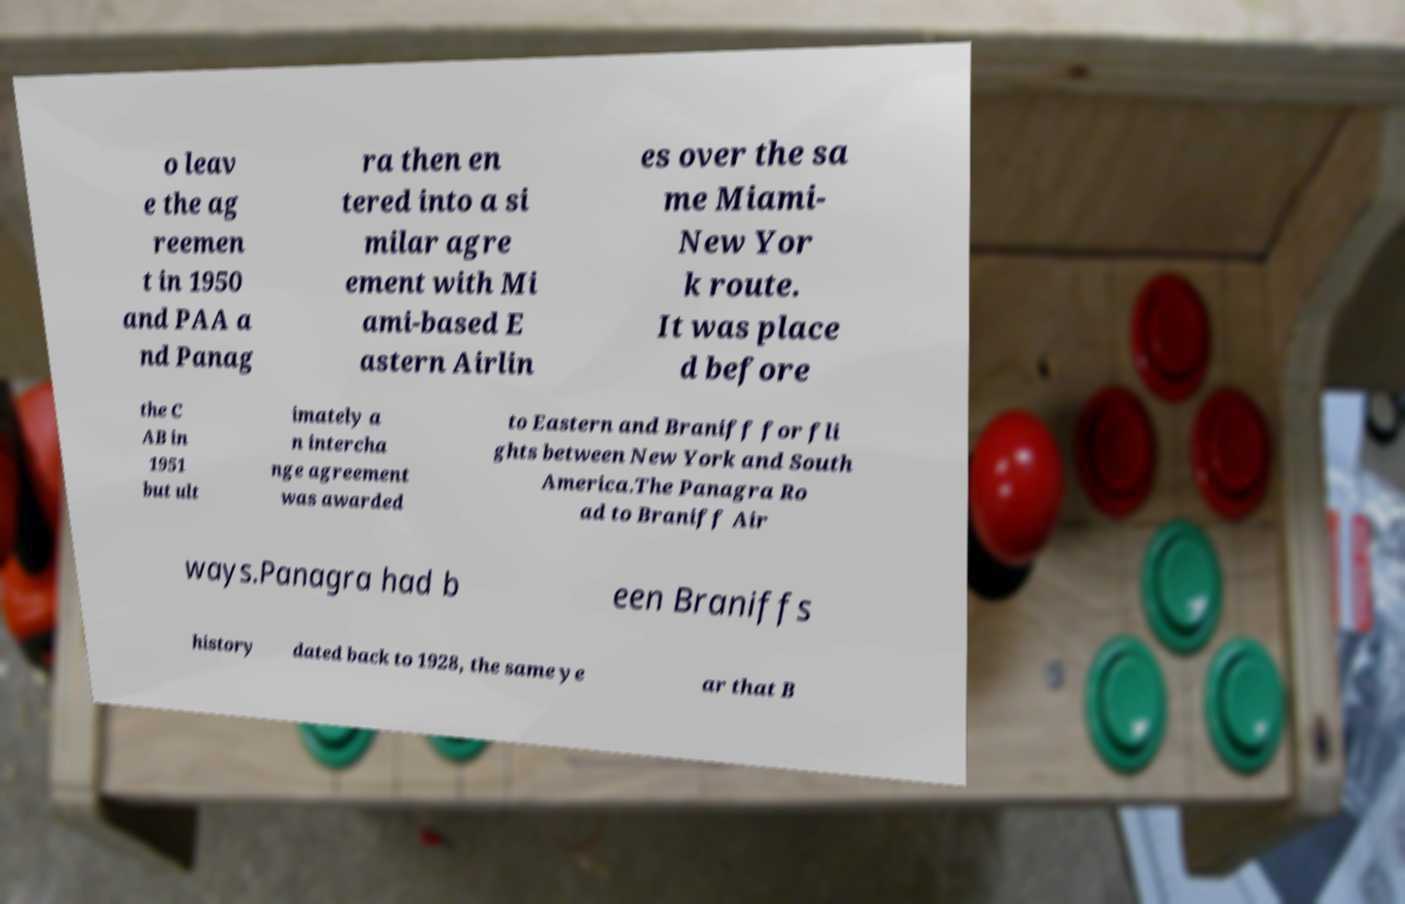I need the written content from this picture converted into text. Can you do that? o leav e the ag reemen t in 1950 and PAA a nd Panag ra then en tered into a si milar agre ement with Mi ami-based E astern Airlin es over the sa me Miami- New Yor k route. It was place d before the C AB in 1951 but ult imately a n intercha nge agreement was awarded to Eastern and Braniff for fli ghts between New York and South America.The Panagra Ro ad to Braniff Air ways.Panagra had b een Braniffs history dated back to 1928, the same ye ar that B 